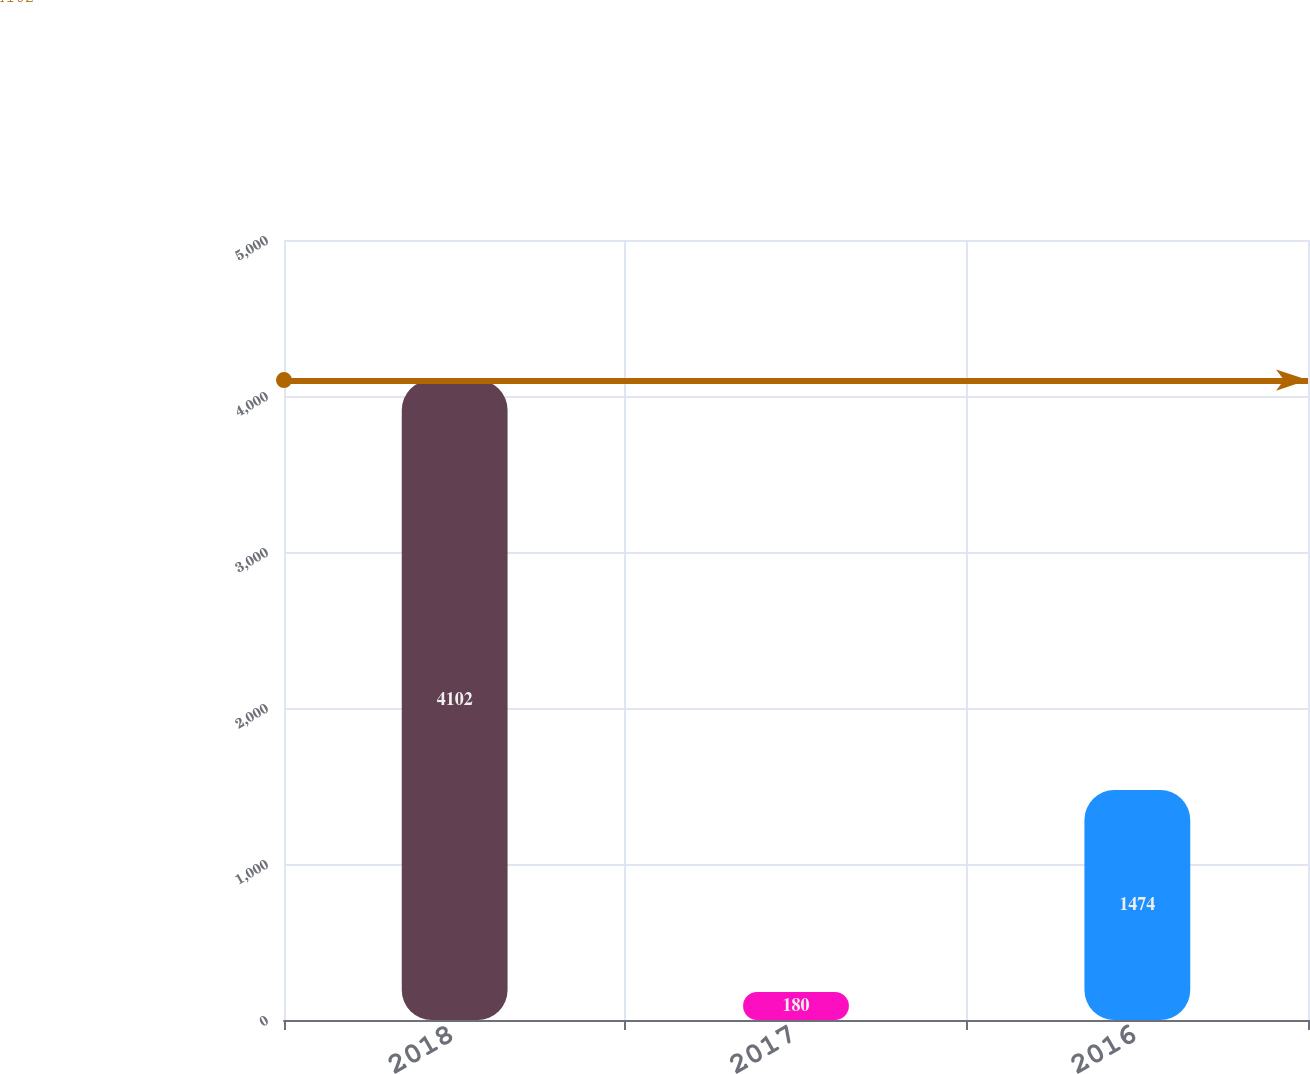Convert chart. <chart><loc_0><loc_0><loc_500><loc_500><bar_chart><fcel>2018<fcel>2017<fcel>2016<nl><fcel>4102<fcel>180<fcel>1474<nl></chart> 